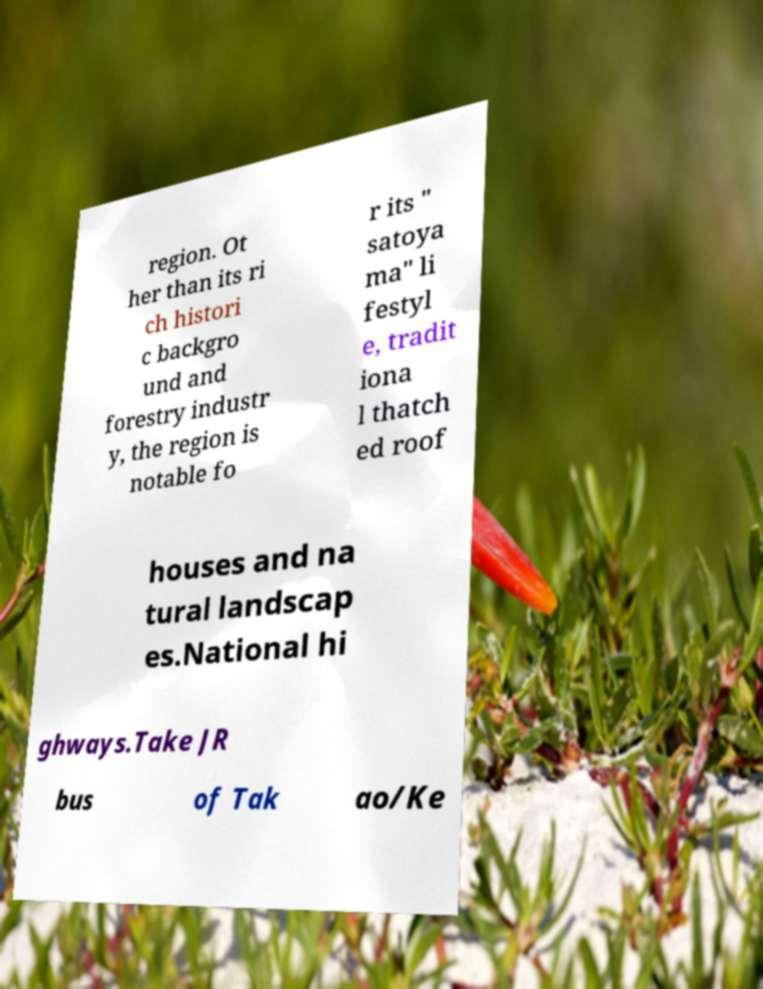Can you accurately transcribe the text from the provided image for me? region. Ot her than its ri ch histori c backgro und and forestry industr y, the region is notable fo r its " satoya ma" li festyl e, tradit iona l thatch ed roof houses and na tural landscap es.National hi ghways.Take JR bus of Tak ao/Ke 